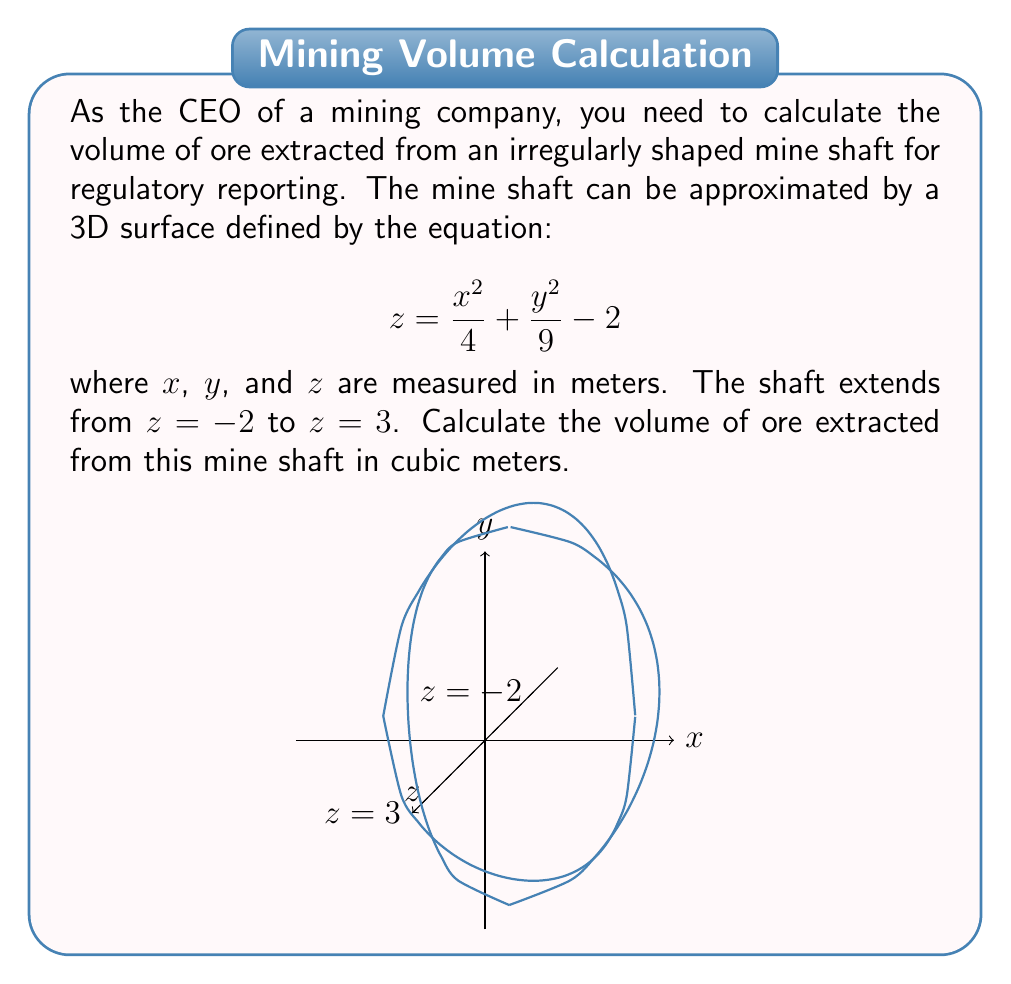Provide a solution to this math problem. To solve this problem, we'll use the method of double integrals to calculate the volume between two surfaces. Here's the step-by-step approach:

1) The volume is bounded by the surface $z = \frac{x^2}{4} + \frac{y^2}{9} - 2$ from below, and the plane $z = 3$ from above.

2) We need to find the projection of the intersection of these surfaces onto the xy-plane. This will give us the limits of integration for x and y.

3) Setting the equations equal:

   $$\frac{x^2}{4} + \frac{y^2}{9} - 2 = 3$$
   $$\frac{x^2}{4} + \frac{y^2}{9} = 5$$

4) This is the equation of an ellipse. The limits for x and y are:

   $$-2\sqrt{5} \leq x \leq 2\sqrt{5}$$
   $$-3\sqrt{5} \leq y \leq 3\sqrt{5}$$

5) The volume is given by the double integral:

   $$V = \int_{-3\sqrt{5}}^{3\sqrt{5}} \int_{-2\sqrt{5}}^{2\sqrt{5}} \left(3 - \left(\frac{x^2}{4} + \frac{y^2}{9} - 2\right)\right) dx dy$$

6) Simplifying the integrand:

   $$V = \int_{-3\sqrt{5}}^{3\sqrt{5}} \int_{-2\sqrt{5}}^{2\sqrt{5}} \left(5 - \frac{x^2}{4} - \frac{y^2}{9}\right) dx dy$$

7) Evaluating the inner integral:

   $$V = \int_{-3\sqrt{5}}^{3\sqrt{5}} \left[5x - \frac{x^3}{12} - \frac{xy^2}{9}\right]_{-2\sqrt{5}}^{2\sqrt{5}} dy$$

8) Substituting the limits:

   $$V = \int_{-3\sqrt{5}}^{3\sqrt{5}} \left(20\sqrt{5} - \frac{40\sqrt{5}}{3} - \frac{4y^2\sqrt{5}}{9}\right) dy$$

9) Evaluating the outer integral:

   $$V = \left[20\sqrt{5}y - \frac{40\sqrt{5}y}{3} - \frac{4y^3\sqrt{5}}{27}\right]_{-3\sqrt{5}}^{3\sqrt{5}}$$

10) Substituting the limits and simplifying:

    $$V = 2\left(120\sqrt{5} - 80\sqrt{5} - 108\sqrt{5}\right) = -136\sqrt{5}$$

Therefore, the volume of ore extracted is $136\sqrt{5}$ cubic meters.
Answer: $136\sqrt{5}$ m³ 